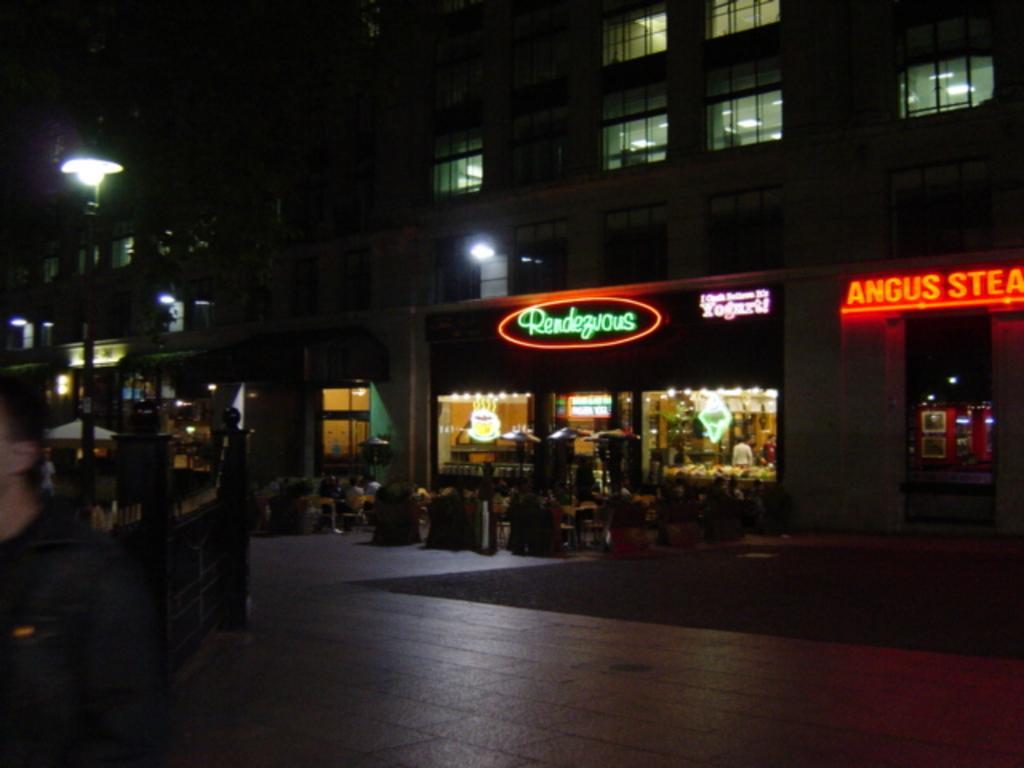Describe this image in one or two sentences. In this picture I can see group of people sitting on the cars, there are plants, light boards, there is a building, there is a pole and this is looking like an umbrella. 